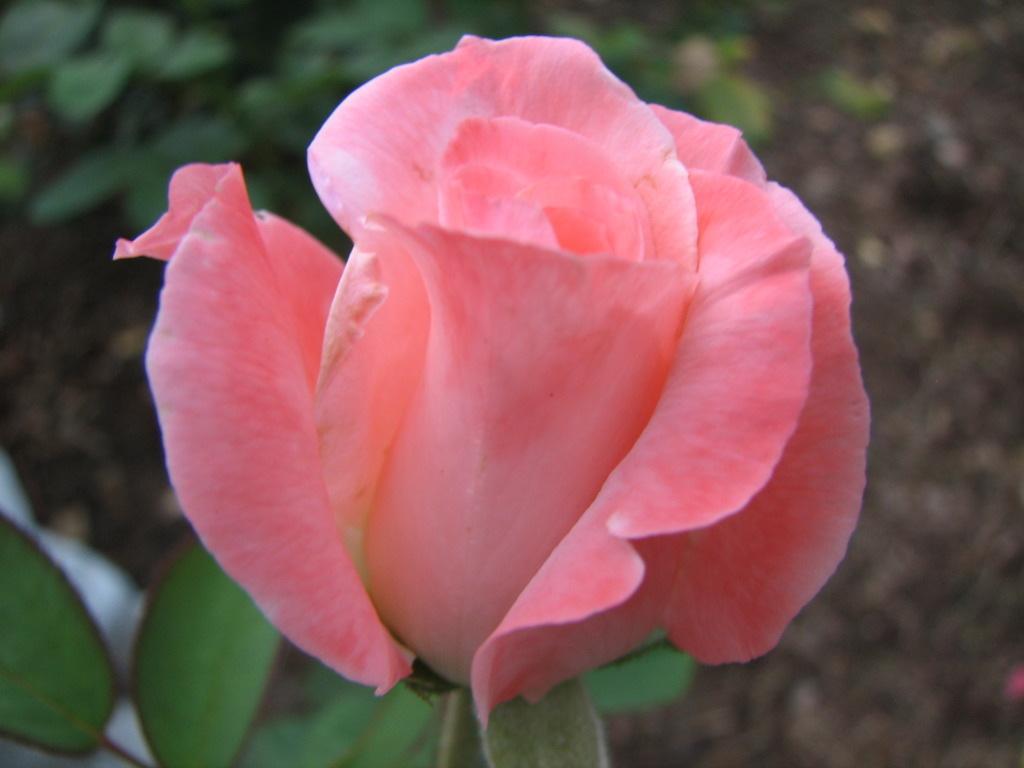Describe this image in one or two sentences. In this picture we see a pink rose flower with green leaves. 